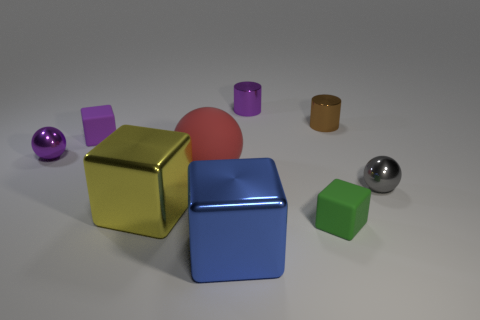Are there more objects left of the purple block than tiny purple cylinders that are in front of the large yellow metal block?
Provide a short and direct response. Yes. Does the tiny gray thing have the same material as the tiny object in front of the large yellow shiny cube?
Your answer should be compact. No. Are there any other things that have the same shape as the big red object?
Your answer should be very brief. Yes. What is the color of the tiny thing that is both on the left side of the small gray sphere and in front of the big red ball?
Make the answer very short. Green. What shape is the tiny matte thing in front of the big yellow shiny block?
Provide a succinct answer. Cube. There is a metal ball that is on the left side of the purple shiny thing to the right of the metallic ball left of the large blue thing; what size is it?
Offer a terse response. Small. How many small purple rubber cubes are on the right side of the tiny block in front of the tiny purple metallic ball?
Provide a short and direct response. 0. There is a shiny object that is right of the blue cube and to the left of the tiny green cube; how big is it?
Keep it short and to the point. Small. What number of matte objects are either big blue cubes or gray cylinders?
Ensure brevity in your answer.  0. What is the material of the big red ball?
Keep it short and to the point. Rubber. 